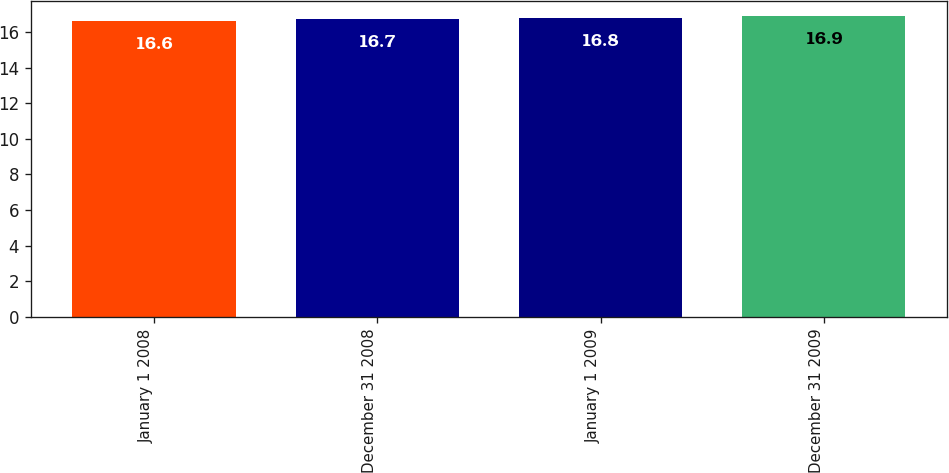Convert chart to OTSL. <chart><loc_0><loc_0><loc_500><loc_500><bar_chart><fcel>January 1 2008<fcel>December 31 2008<fcel>January 1 2009<fcel>December 31 2009<nl><fcel>16.6<fcel>16.7<fcel>16.8<fcel>16.9<nl></chart> 